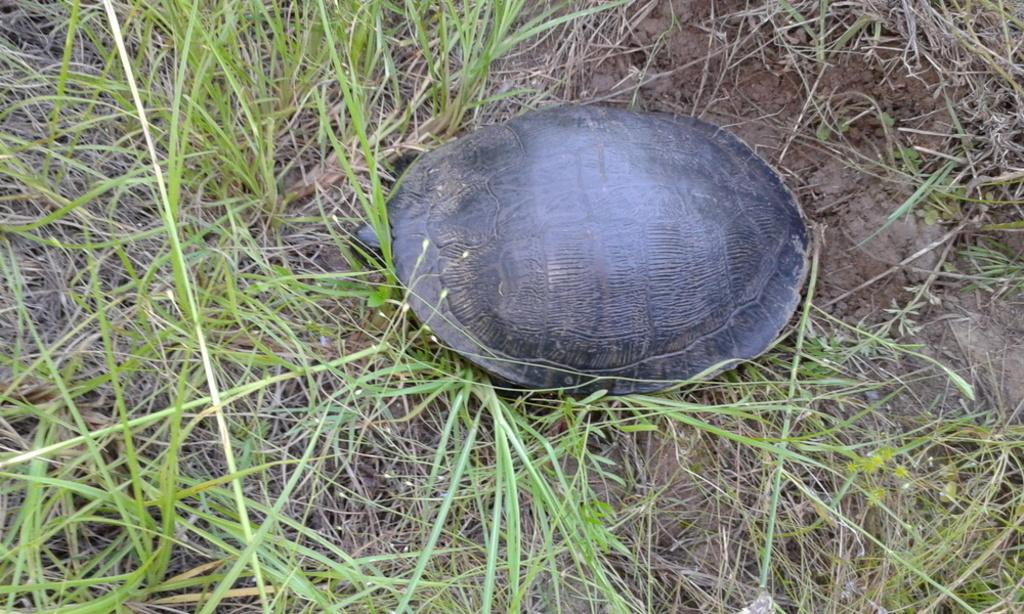What type of animal is in the image? There is a tortoise in the image. What is the tortoise's environment in the image? The tortoise is on grassy land. What type of furniture is the tortoise using for lunch in the image? There is no furniture or lunch depicted in the image; it only features a tortoise on grassy land. 